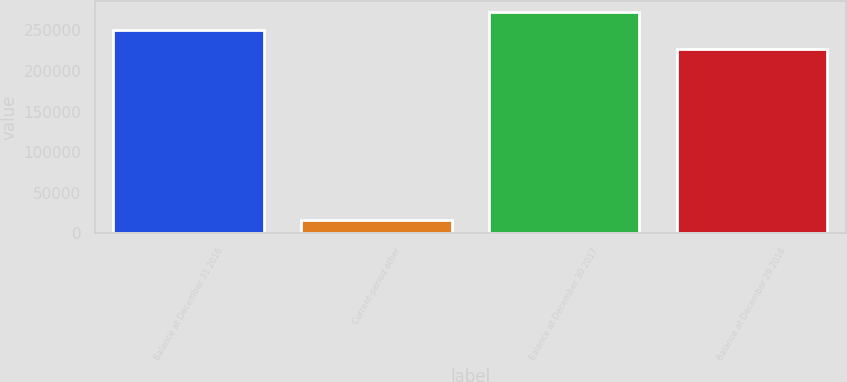<chart> <loc_0><loc_0><loc_500><loc_500><bar_chart><fcel>Balance at December 31 2016<fcel>Current-period other<fcel>Balance at December 30 2017<fcel>Balance at December 29 2018<nl><fcel>250389<fcel>15976<fcel>273168<fcel>227611<nl></chart> 